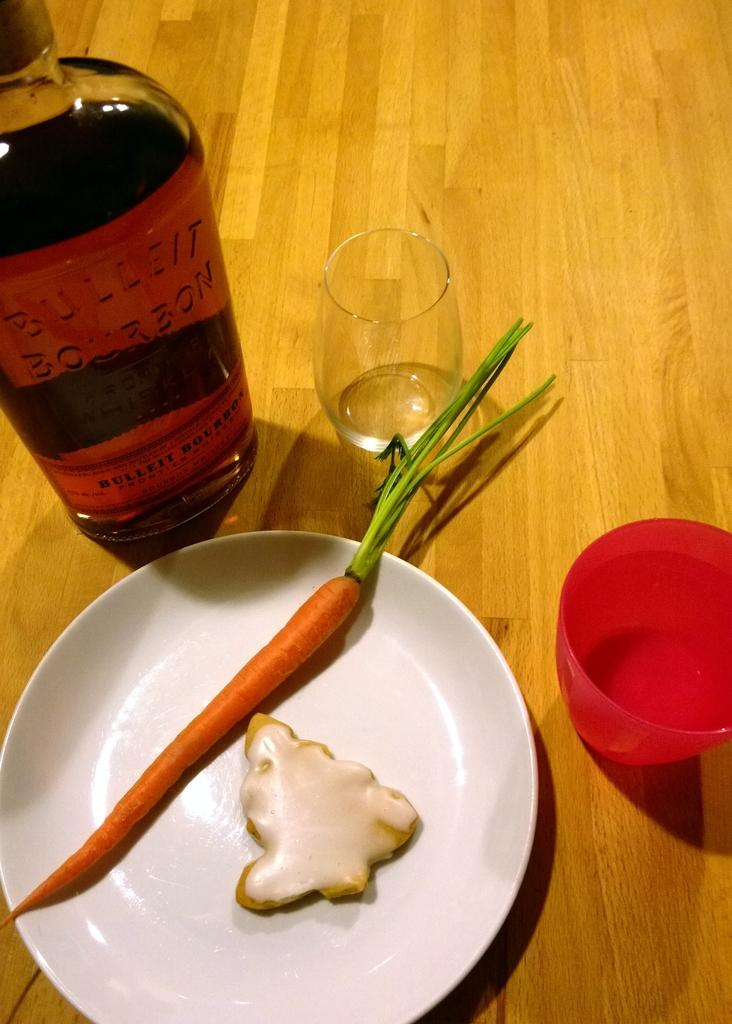<image>
Describe the image concisely. plate with a carrot and smothing that looks like a glazed tree next to a bottle of bulleit bourbon 